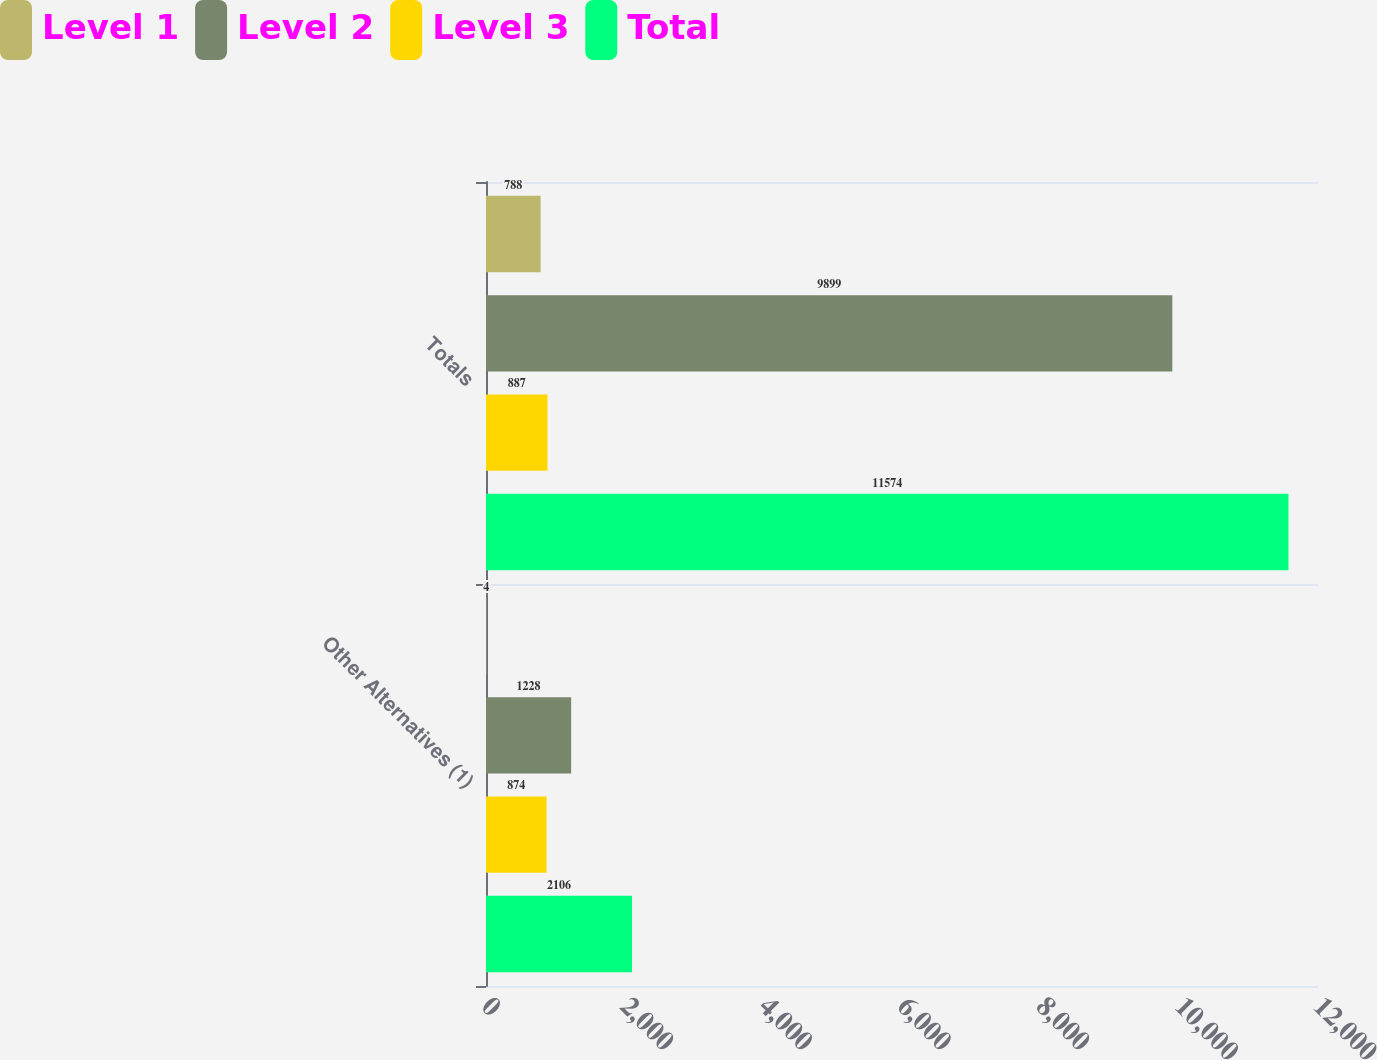<chart> <loc_0><loc_0><loc_500><loc_500><stacked_bar_chart><ecel><fcel>Other Alternatives (1)<fcel>Totals<nl><fcel>Level 1<fcel>4<fcel>788<nl><fcel>Level 2<fcel>1228<fcel>9899<nl><fcel>Level 3<fcel>874<fcel>887<nl><fcel>Total<fcel>2106<fcel>11574<nl></chart> 